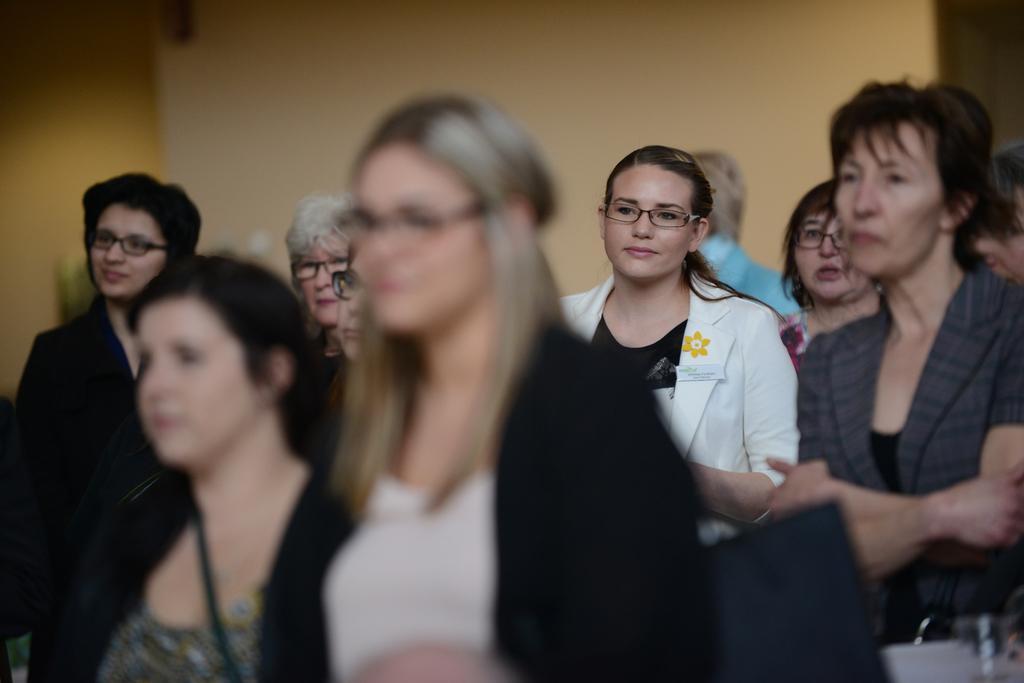Describe this image in one or two sentences. In this image I can see group of people, in front the person is wearing black jacket. Background I can see the other person wearing is white color coat and the wall is in lite yellow color. 